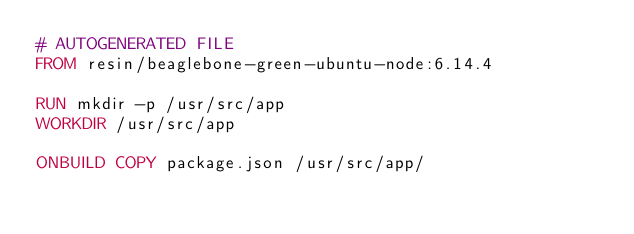<code> <loc_0><loc_0><loc_500><loc_500><_Dockerfile_># AUTOGENERATED FILE
FROM resin/beaglebone-green-ubuntu-node:6.14.4

RUN mkdir -p /usr/src/app
WORKDIR /usr/src/app

ONBUILD COPY package.json /usr/src/app/</code> 